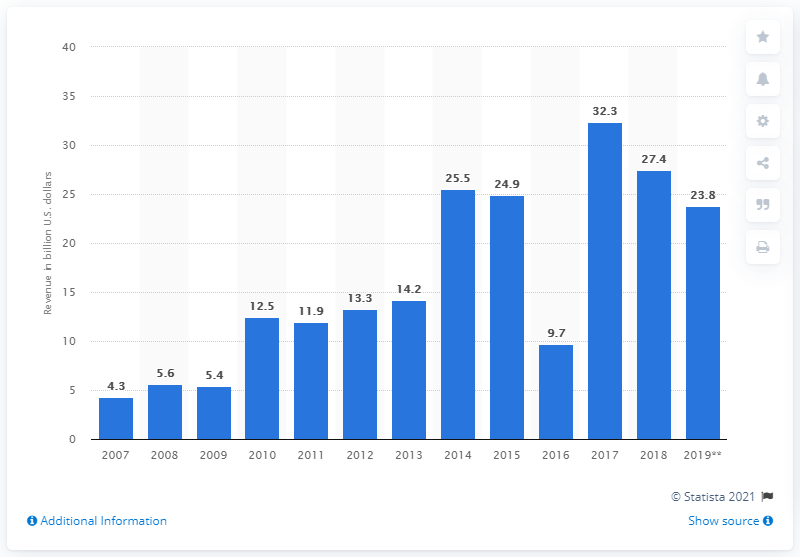Outline some significant characteristics in this image. The total product revenues in the U.S. for products launched 5 years before was 27.4. 